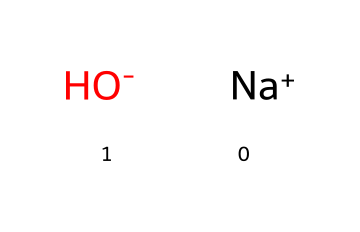What is the molecular formula of this chemical? The chemical representation shows sodium (Na) and hydroxide (OH). Sodium contributes one atom, and hydroxide contributes one oxygen atom and one hydrogen atom, forming the molecular formula NaOH.
Answer: NaOH How many atoms are present in the chemical structure? In the chemical, there are three atoms: one sodium atom, one oxygen atom, and one hydrogen atom within the hydroxide ion (OH).
Answer: three What type of ion is sodium in this compound? Sodium is shown as [Na+] in the structure, indicating that it has a positive charge, thus it is a cation.
Answer: cation What property makes sodium hydroxide a strong base? The presence of hydroxide ions (OH-) in the structure indicates that it can readily accept protons (H+), making it a strong base.
Answer: hydroxide ions What is the charge of the hydroxide ion in this compound? The hydroxide is represented as [OH-], indicating it carries a negative charge, which is essential for its basicity.
Answer: negative What is the role of sodium in sodium hydroxide? Sodium acts as a counterion to balance the charge of the hydroxide ion, stabilizing the overall compound, which is essential for its solubility and basic properties.
Answer: counterion Is sodium hydroxide considered an electrolyte? Sodium hydroxide dissociates in water into sodium ions and hydroxide ions, allowing it to conduct electricity, thus classifying it as an electrolyte.
Answer: yes 